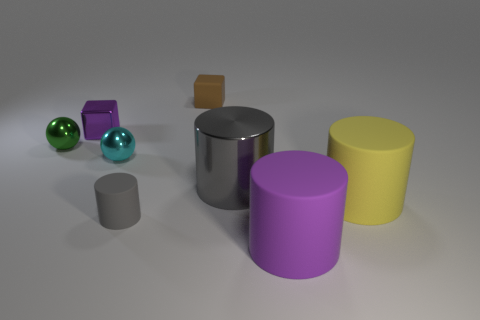The large metal thing is what color?
Make the answer very short. Gray. What is the material of the big thing that is behind the purple rubber thing and left of the large yellow cylinder?
Provide a short and direct response. Metal. There is a large matte cylinder that is behind the purple thing in front of the green thing; are there any gray things that are in front of it?
Your answer should be very brief. Yes. There is a cylinder that is the same color as the large metallic object; what size is it?
Offer a terse response. Small. There is a tiny cyan thing; are there any tiny shiny things behind it?
Your answer should be compact. Yes. How many other things are the same shape as the yellow thing?
Keep it short and to the point. 3. What is the color of the rubber cylinder that is the same size as the green ball?
Your answer should be very brief. Gray. Is the number of big yellow objects left of the tiny cyan metallic thing less than the number of large yellow objects to the left of the tiny metal cube?
Provide a succinct answer. No. How many tiny metallic objects are to the right of the purple shiny thing that is left of the cube on the right side of the small cyan object?
Ensure brevity in your answer.  1. What is the size of the brown object that is the same shape as the tiny purple object?
Offer a terse response. Small. 